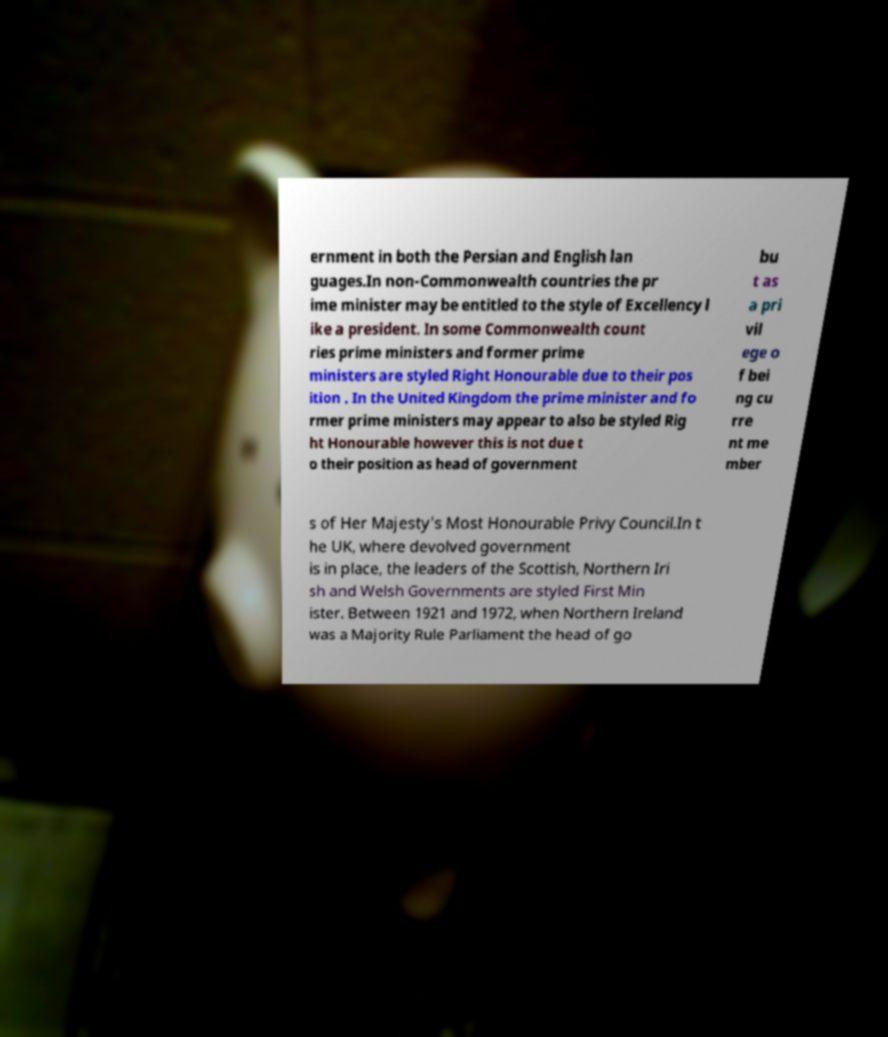Could you extract and type out the text from this image? ernment in both the Persian and English lan guages.In non-Commonwealth countries the pr ime minister may be entitled to the style of Excellency l ike a president. In some Commonwealth count ries prime ministers and former prime ministers are styled Right Honourable due to their pos ition . In the United Kingdom the prime minister and fo rmer prime ministers may appear to also be styled Rig ht Honourable however this is not due t o their position as head of government bu t as a pri vil ege o f bei ng cu rre nt me mber s of Her Majesty's Most Honourable Privy Council.In t he UK, where devolved government is in place, the leaders of the Scottish, Northern Iri sh and Welsh Governments are styled First Min ister. Between 1921 and 1972, when Northern Ireland was a Majority Rule Parliament the head of go 